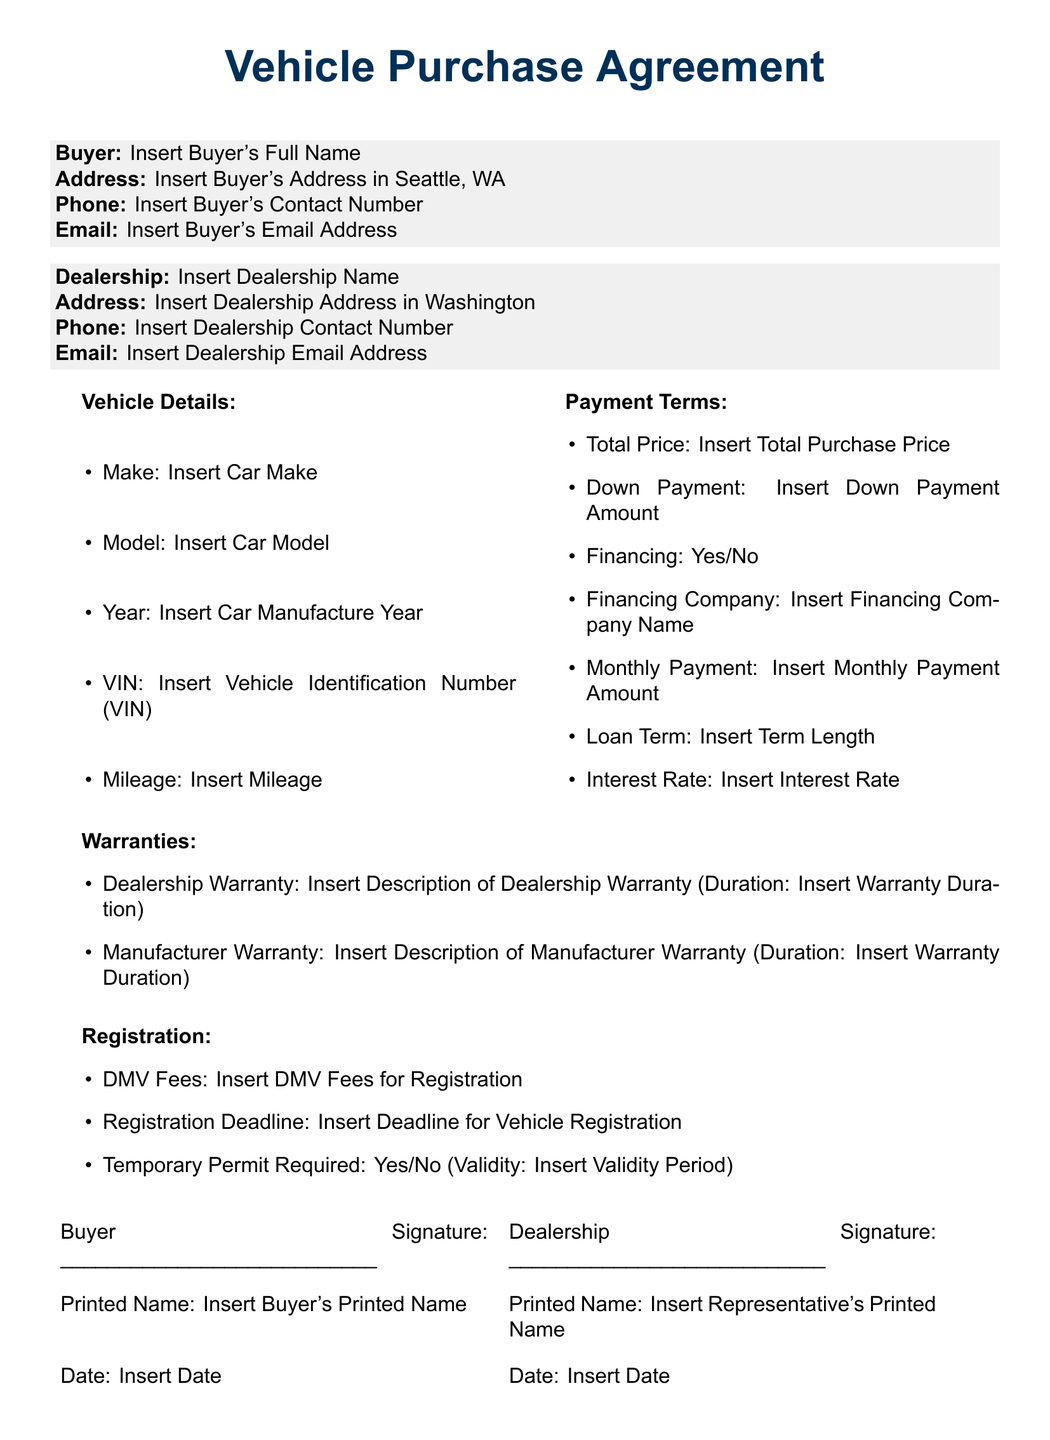What is the total price? The total price is listed under the Payment Terms section, which is Insert Total Purchase Price.
Answer: Insert Total Purchase Price What is the down payment amount? The down payment amount can be found in the Payment Terms section, specified as Insert Down Payment Amount.
Answer: Insert Down Payment Amount What is the VIN? The VIN can be found in the Vehicle Details section as Insert Vehicle Identification Number (VIN).
Answer: Insert Vehicle Identification Number (VIN) What is the dealership name? The dealership name is provided in the Dealership section as Insert Dealership Name.
Answer: Insert Dealership Name What is the validity period of the temporary permit? The validity period of the temporary permit can be located under Registration section, designated as Insert Validity Period.
Answer: Insert Validity Period How long is the dealership warranty? The duration of the dealership warranty is mentioned in the Warranties section as Insert Warranty Duration.
Answer: Insert Warranty Duration What is the registration deadline? The registration deadline is specified in the Registration section as Insert Deadline for Vehicle Registration.
Answer: Insert Deadline for Vehicle Registration Is financing available? The availability of financing is indicated under Payment Terms with a Yes/No answer.
Answer: Yes/No 